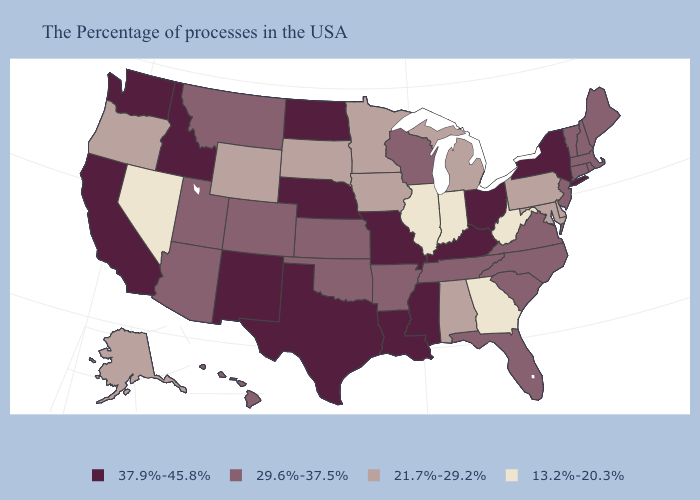Name the states that have a value in the range 13.2%-20.3%?
Answer briefly. West Virginia, Georgia, Indiana, Illinois, Nevada. Does Oklahoma have the highest value in the USA?
Short answer required. No. Among the states that border Georgia , does Alabama have the lowest value?
Quick response, please. Yes. What is the value of Colorado?
Answer briefly. 29.6%-37.5%. What is the lowest value in the USA?
Keep it brief. 13.2%-20.3%. What is the value of Georgia?
Give a very brief answer. 13.2%-20.3%. What is the lowest value in states that border New Hampshire?
Give a very brief answer. 29.6%-37.5%. Which states have the highest value in the USA?
Concise answer only. New York, Ohio, Kentucky, Mississippi, Louisiana, Missouri, Nebraska, Texas, North Dakota, New Mexico, Idaho, California, Washington. Name the states that have a value in the range 29.6%-37.5%?
Keep it brief. Maine, Massachusetts, Rhode Island, New Hampshire, Vermont, Connecticut, New Jersey, Virginia, North Carolina, South Carolina, Florida, Tennessee, Wisconsin, Arkansas, Kansas, Oklahoma, Colorado, Utah, Montana, Arizona, Hawaii. What is the highest value in the USA?
Answer briefly. 37.9%-45.8%. Does New York have a higher value than Louisiana?
Keep it brief. No. What is the value of Arkansas?
Quick response, please. 29.6%-37.5%. Name the states that have a value in the range 13.2%-20.3%?
Quick response, please. West Virginia, Georgia, Indiana, Illinois, Nevada. Name the states that have a value in the range 13.2%-20.3%?
Be succinct. West Virginia, Georgia, Indiana, Illinois, Nevada. 